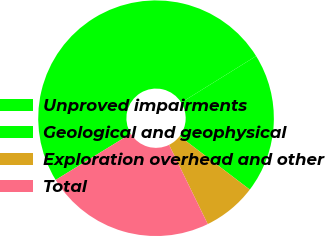Convert chart. <chart><loc_0><loc_0><loc_500><loc_500><pie_chart><fcel>Unproved impairments<fcel>Geological and geophysical<fcel>Exploration overhead and other<fcel>Total<nl><fcel>49.93%<fcel>19.2%<fcel>7.41%<fcel>23.46%<nl></chart> 